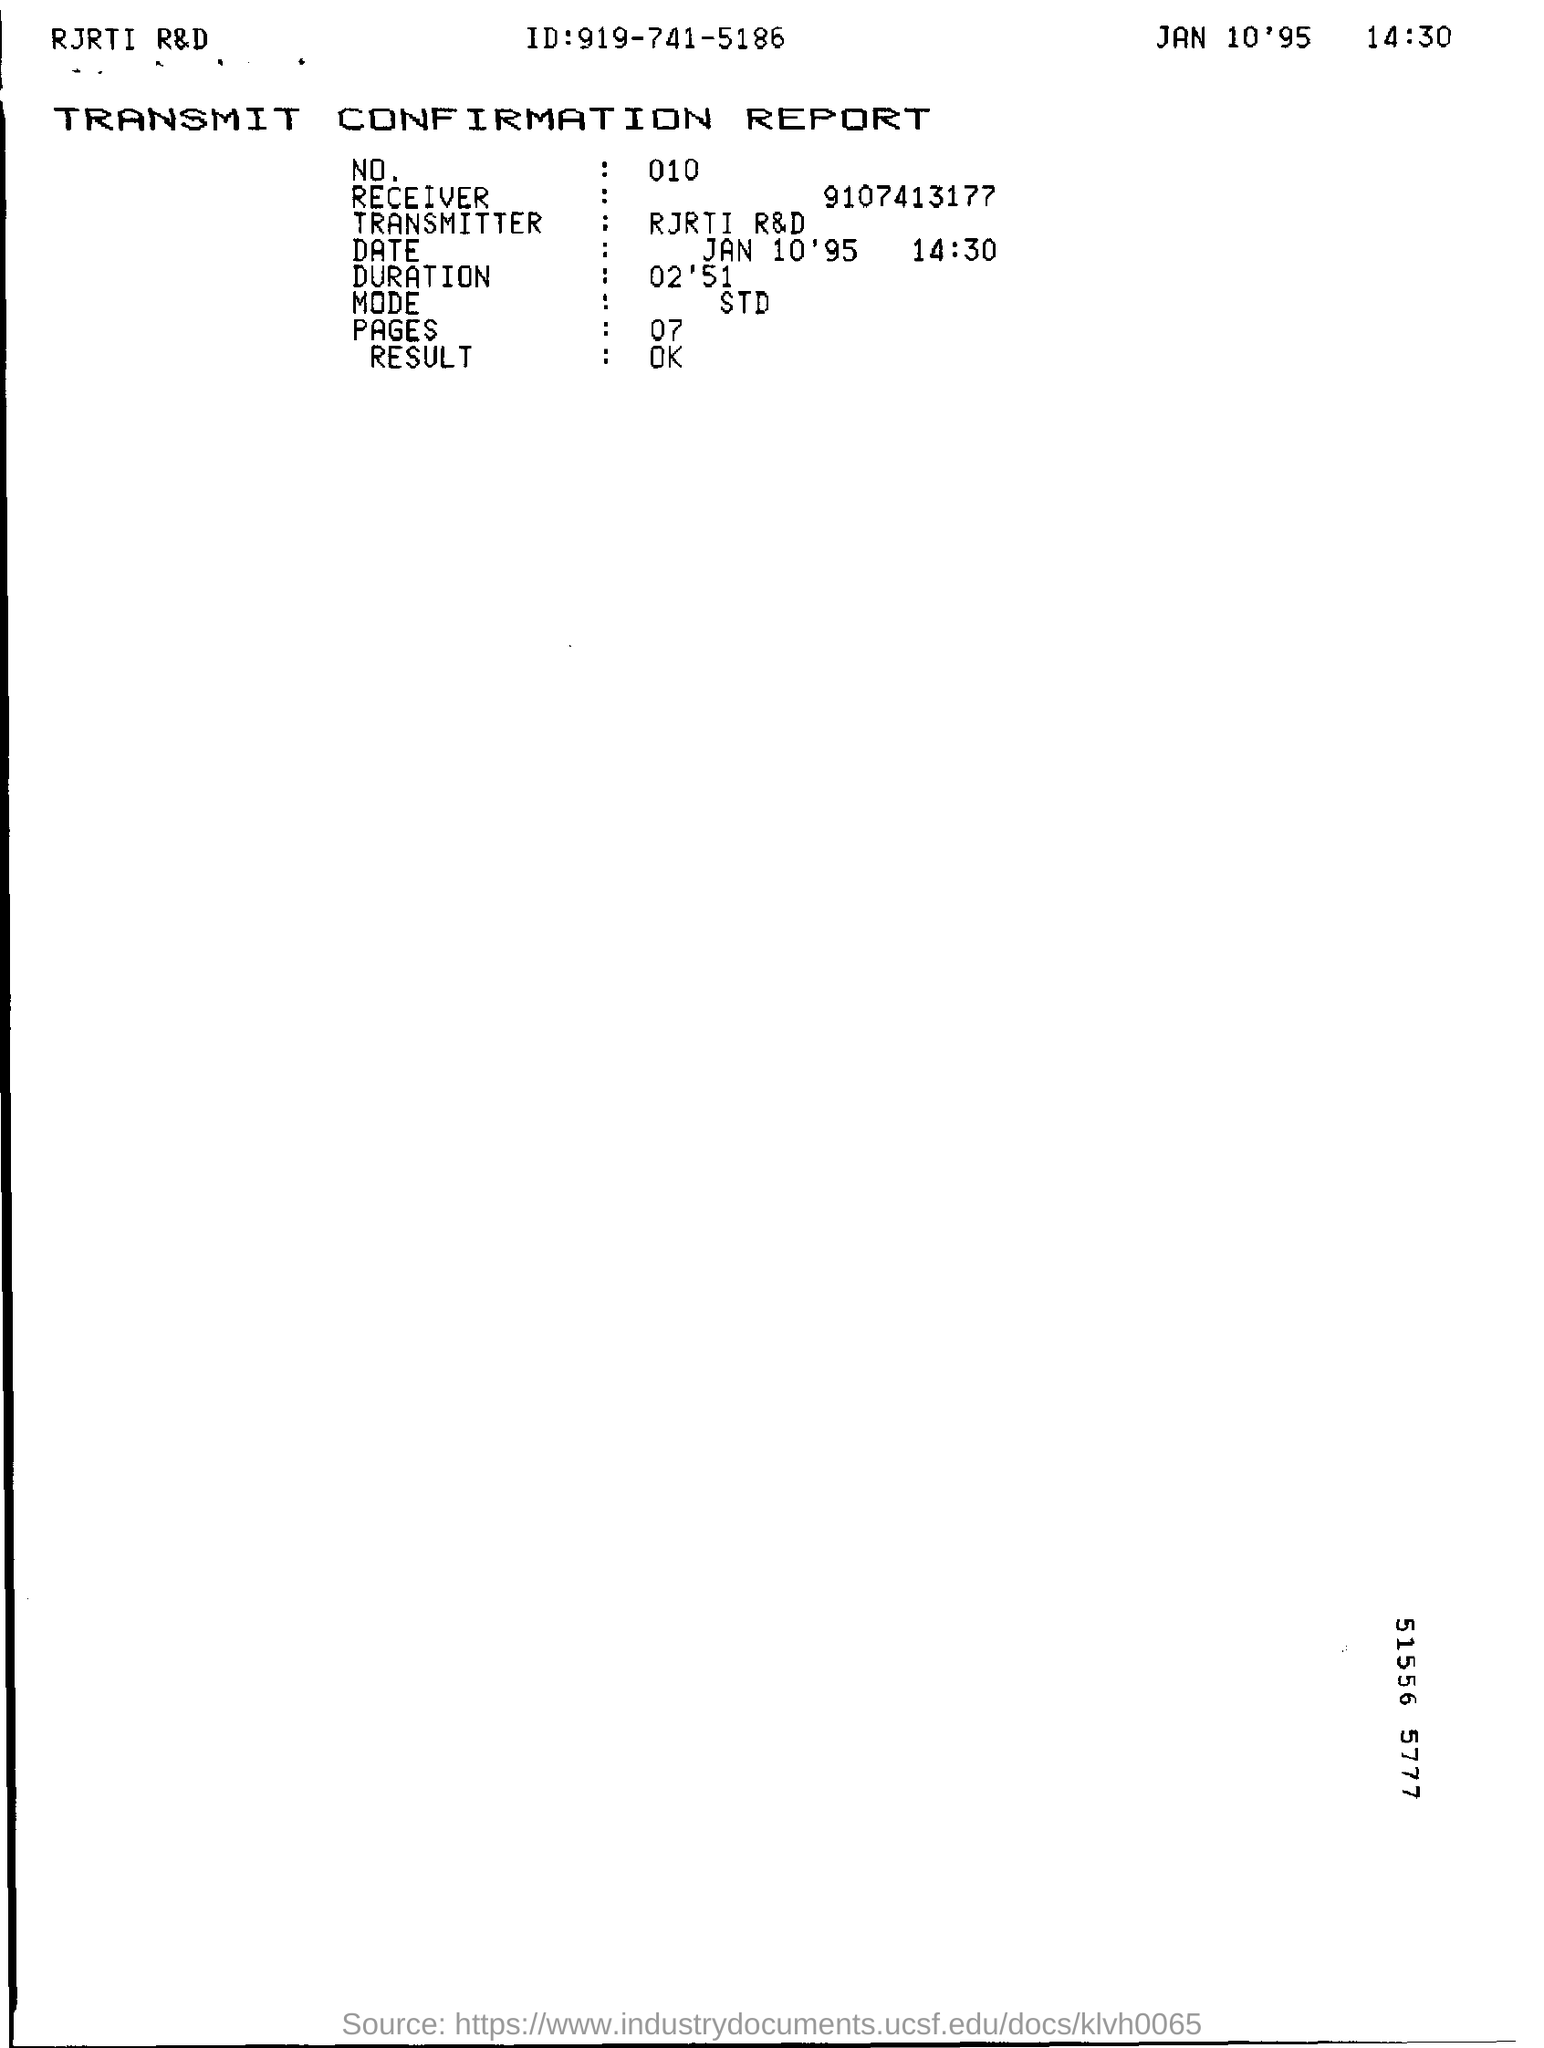What report is given here?
Your response must be concise. TRANSMIT CONFIRMATION REPORT. What is the Date & time mentioned in the report?
Ensure brevity in your answer.  JAN 10'95         14:30. How many pages are mentioned in the report?
Give a very brief answer. 07. What is the ID given in the report?
Ensure brevity in your answer.  919-741-5186. What is the duration as per the report?
Provide a succinct answer. 02'51. What is the NO mentioned in the report?
Provide a short and direct response. 010. 